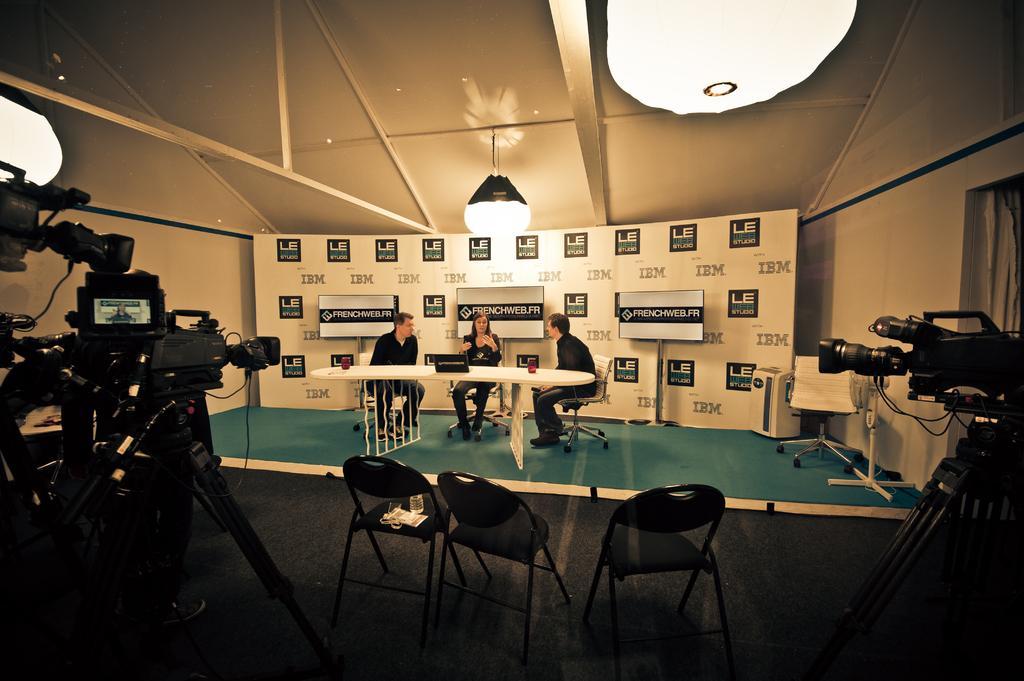In one or two sentences, can you explain what this image depicts? This image is taken inside a room. There are three people in this image, sitting on the chairs, two men and a woman. In the middle of the image there is a table and few empty chairs. In the left side of the image there is a camera with stand. In the right side of the image there is a window with curtains and a camera. In the bottom of the image there is a floor. In the background there is a wall and a poster with text on it. At the top of the image there is a ceiling with lights. 